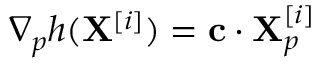<formula> <loc_0><loc_0><loc_500><loc_500>\nabla _ { p } h ( X ^ { [ i ] } ) = c \cdot X _ { p } ^ { [ i ] }</formula> 